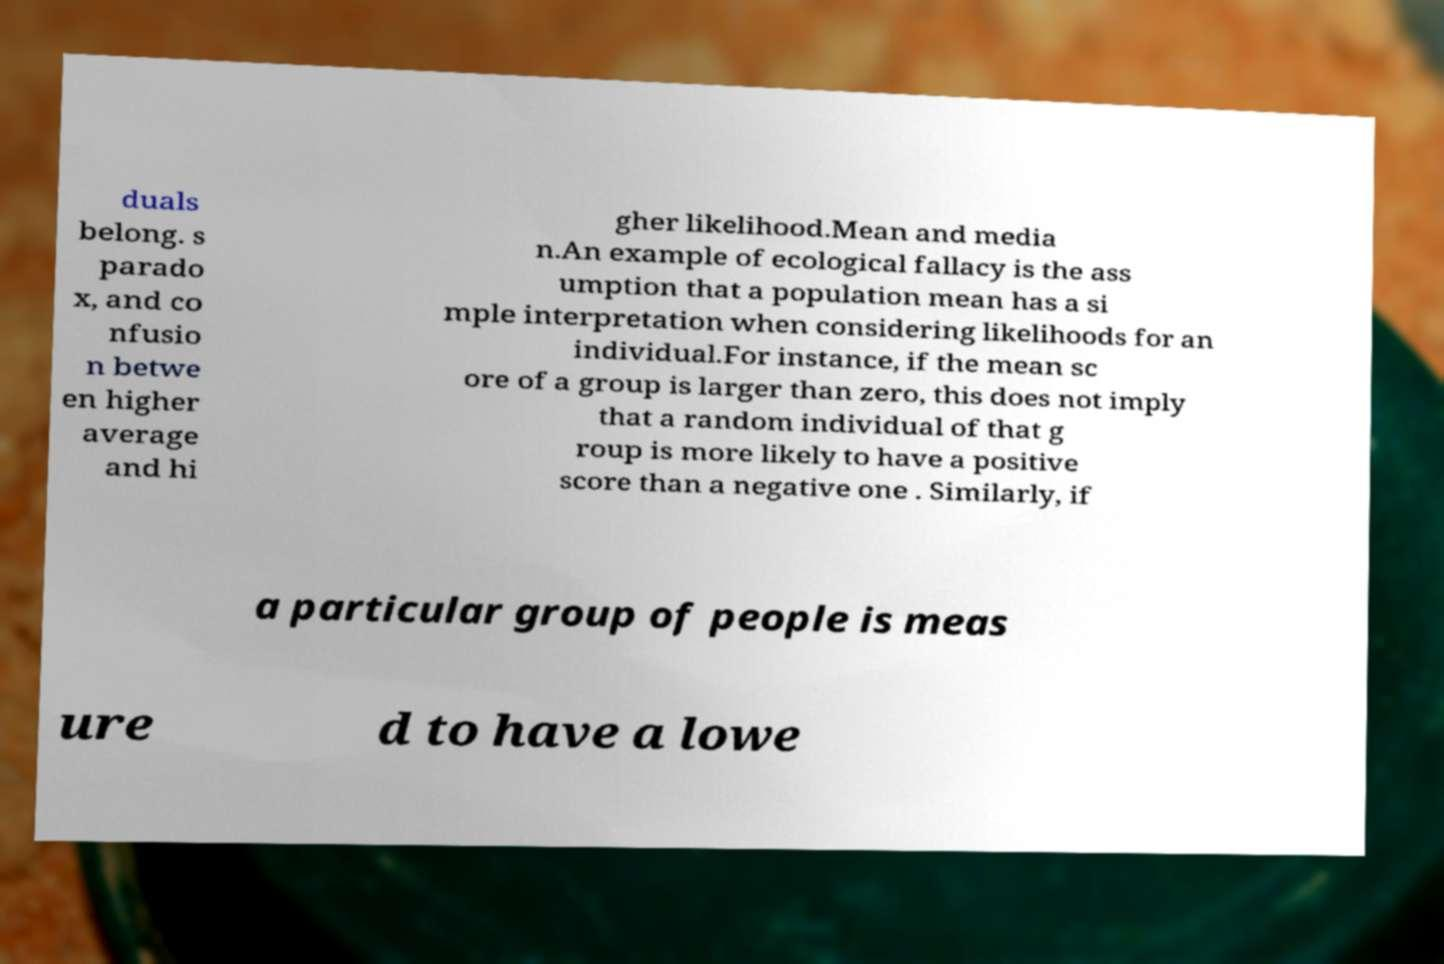Can you read and provide the text displayed in the image?This photo seems to have some interesting text. Can you extract and type it out for me? duals belong. s parado x, and co nfusio n betwe en higher average and hi gher likelihood.Mean and media n.An example of ecological fallacy is the ass umption that a population mean has a si mple interpretation when considering likelihoods for an individual.For instance, if the mean sc ore of a group is larger than zero, this does not imply that a random individual of that g roup is more likely to have a positive score than a negative one . Similarly, if a particular group of people is meas ure d to have a lowe 